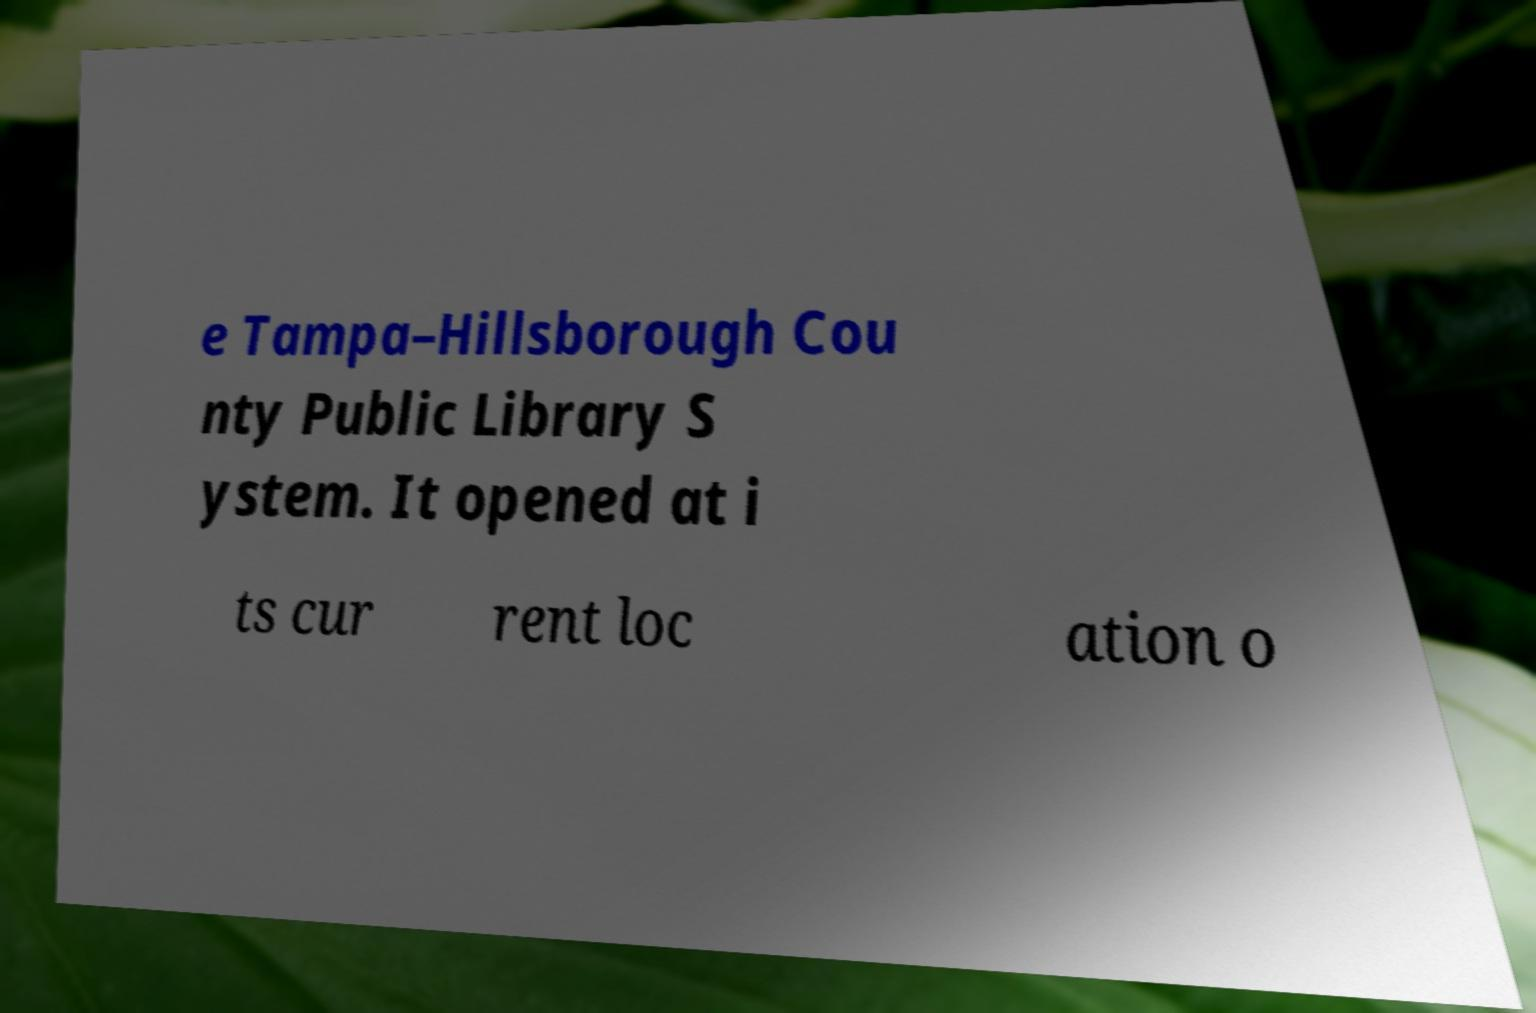There's text embedded in this image that I need extracted. Can you transcribe it verbatim? e Tampa–Hillsborough Cou nty Public Library S ystem. It opened at i ts cur rent loc ation o 